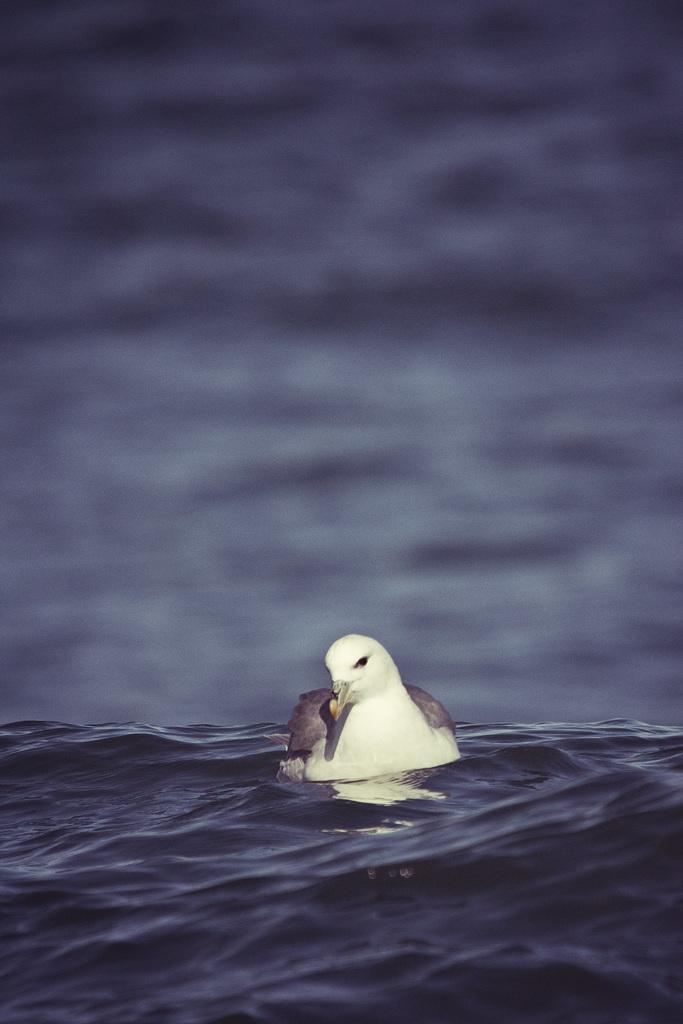Please provide a concise description of this image. In this image I can see a bird in the water. The background is blurred. 